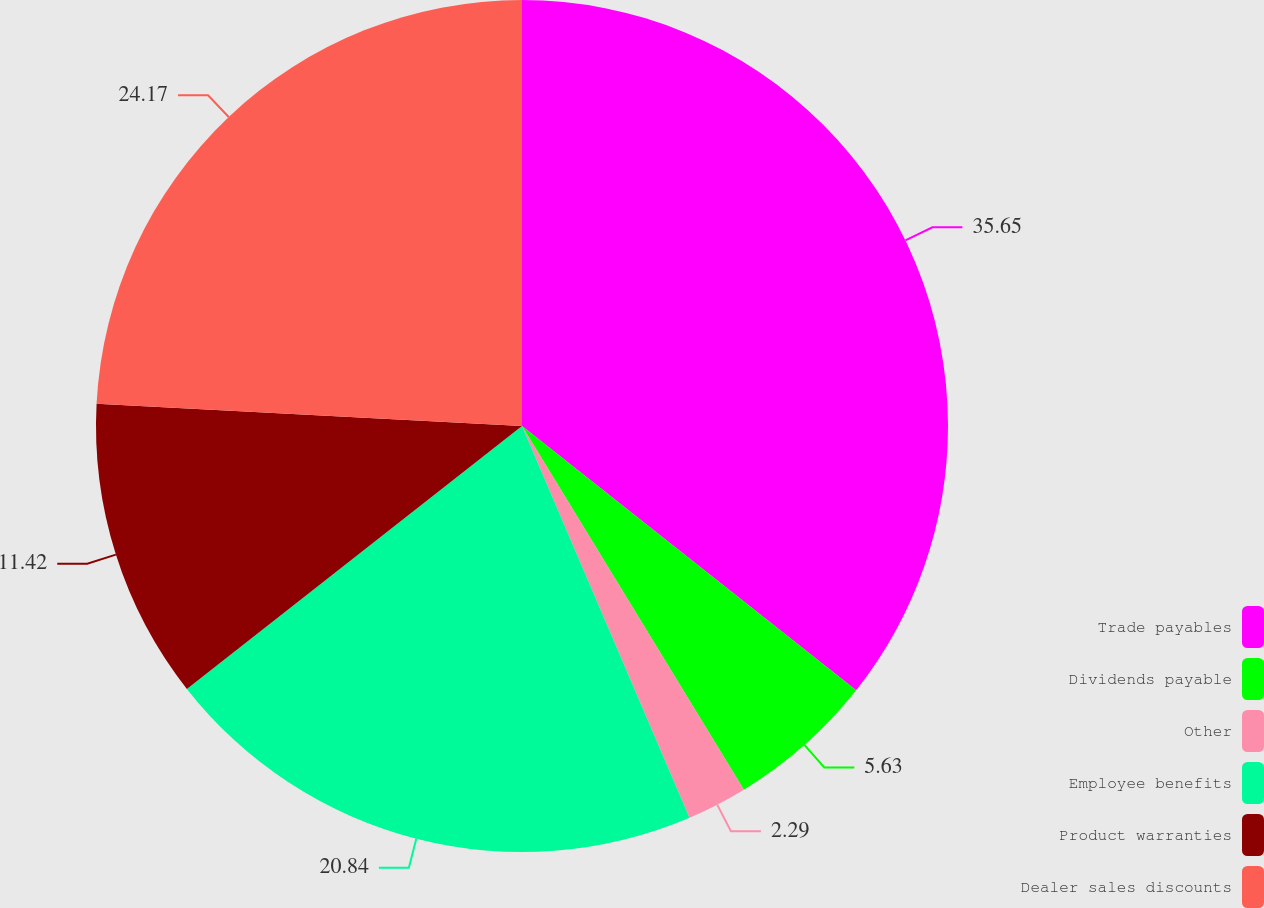Convert chart to OTSL. <chart><loc_0><loc_0><loc_500><loc_500><pie_chart><fcel>Trade payables<fcel>Dividends payable<fcel>Other<fcel>Employee benefits<fcel>Product warranties<fcel>Dealer sales discounts<nl><fcel>35.65%<fcel>5.63%<fcel>2.29%<fcel>20.84%<fcel>11.42%<fcel>24.17%<nl></chart> 